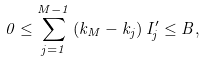Convert formula to latex. <formula><loc_0><loc_0><loc_500><loc_500>0 \leq \sum _ { j = 1 } ^ { M - 1 } \left ( k _ { M } - k _ { j } \right ) I _ { j } ^ { \prime } \leq B ,</formula> 